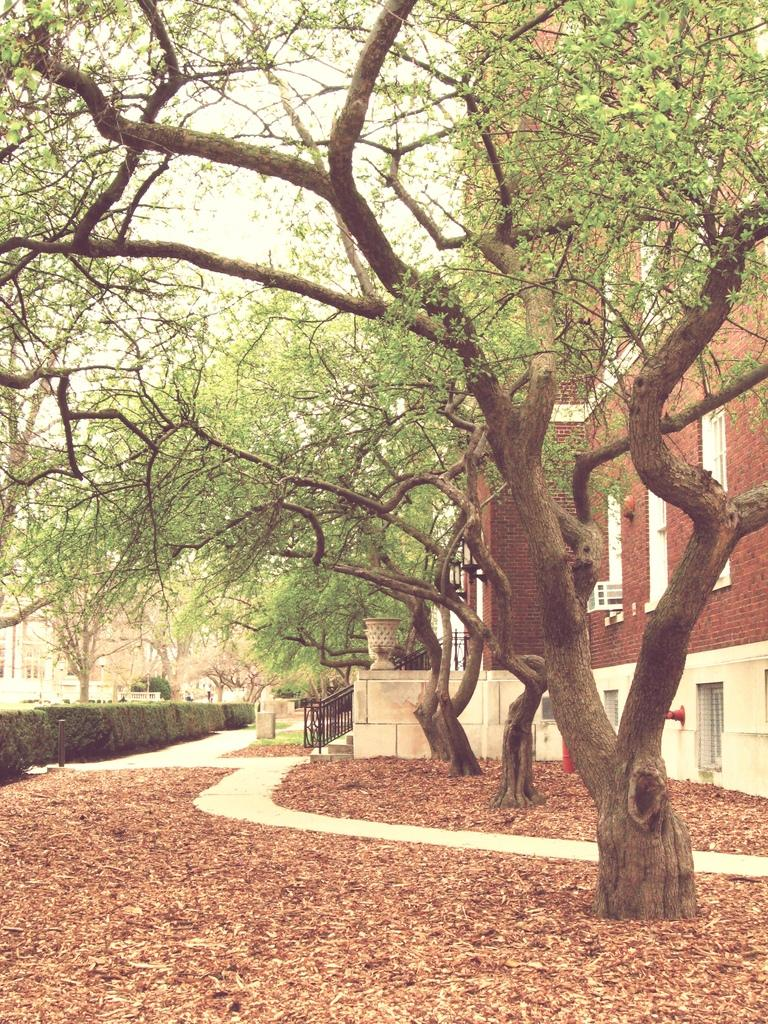What type of vegetation can be seen in the image? There are trees and bushes in the image. What structures are visible in the image? There are buildings in the image. What is in front of the bushes? There is a metal fence in front of the bushes. What is present on the surface in the image? Dry leaves are present on the surface. What type of rhythm can be heard coming from the house in the image? There is no house present in the image, so it is not possible to determine what rhythm might be heard. 